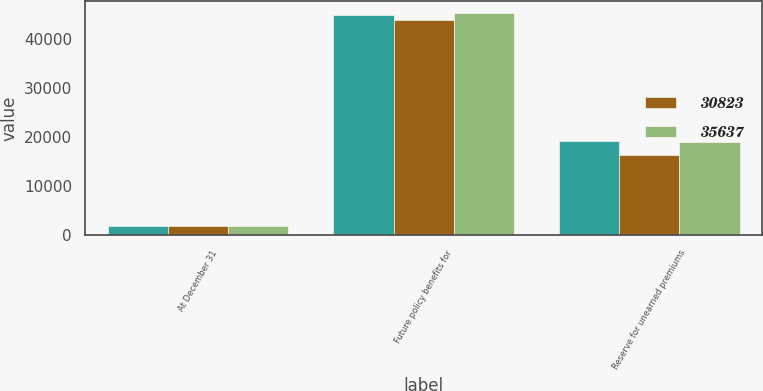<chart> <loc_0><loc_0><loc_500><loc_500><stacked_bar_chart><ecel><fcel>At December 31<fcel>Future policy benefits for<fcel>Reserve for unearned premiums<nl><fcel>nan<fcel>2018<fcel>44935<fcel>19248<nl><fcel>30823<fcel>2018<fcel>43936<fcel>16300<nl><fcel>35637<fcel>2017<fcel>45432<fcel>19030<nl></chart> 